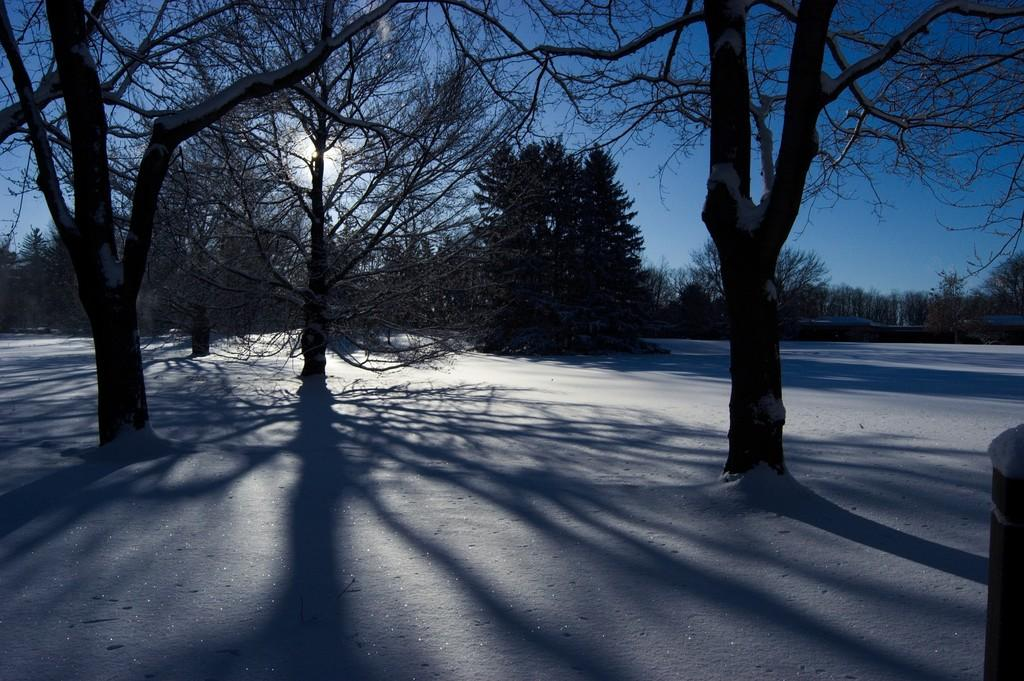What is the main feature of the image? The main feature of the image is the many trees. What is the condition of the ground in the image? The trees are on a snow surface. How are the trees affected by the weather conditions? The trees are covered with ice. Can you see the roots of the trees in the image? There is no indication of the trees' roots in the image, as the focus is on the trees' branches and the snowy surface. 